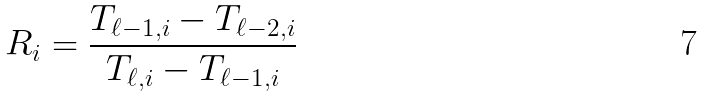<formula> <loc_0><loc_0><loc_500><loc_500>R _ { i } = \frac { T _ { \ell - 1 , i } - T _ { \ell - 2 , i } } { T _ { \ell , i } - T _ { \ell - 1 , i } }</formula> 